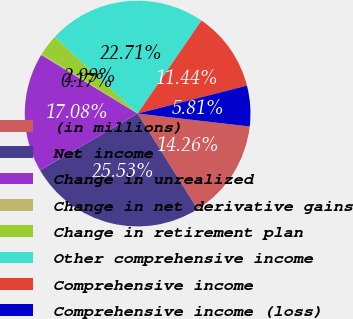<chart> <loc_0><loc_0><loc_500><loc_500><pie_chart><fcel>(in millions)<fcel>Net income<fcel>Change in unrealized<fcel>Change in net derivative gains<fcel>Change in retirement plan<fcel>Other comprehensive income<fcel>Comprehensive income<fcel>Comprehensive income (loss)<nl><fcel>14.26%<fcel>25.53%<fcel>17.08%<fcel>0.17%<fcel>2.99%<fcel>22.71%<fcel>11.44%<fcel>5.81%<nl></chart> 